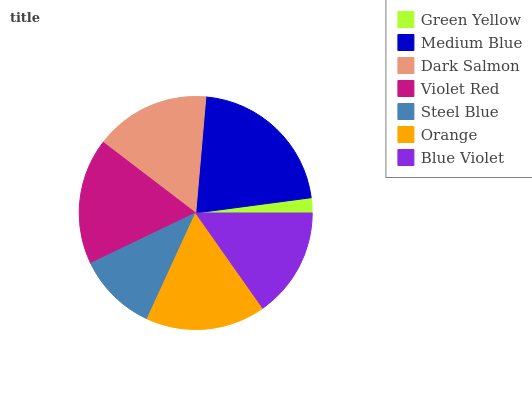Is Green Yellow the minimum?
Answer yes or no. Yes. Is Medium Blue the maximum?
Answer yes or no. Yes. Is Dark Salmon the minimum?
Answer yes or no. No. Is Dark Salmon the maximum?
Answer yes or no. No. Is Medium Blue greater than Dark Salmon?
Answer yes or no. Yes. Is Dark Salmon less than Medium Blue?
Answer yes or no. Yes. Is Dark Salmon greater than Medium Blue?
Answer yes or no. No. Is Medium Blue less than Dark Salmon?
Answer yes or no. No. Is Dark Salmon the high median?
Answer yes or no. Yes. Is Dark Salmon the low median?
Answer yes or no. Yes. Is Blue Violet the high median?
Answer yes or no. No. Is Violet Red the low median?
Answer yes or no. No. 